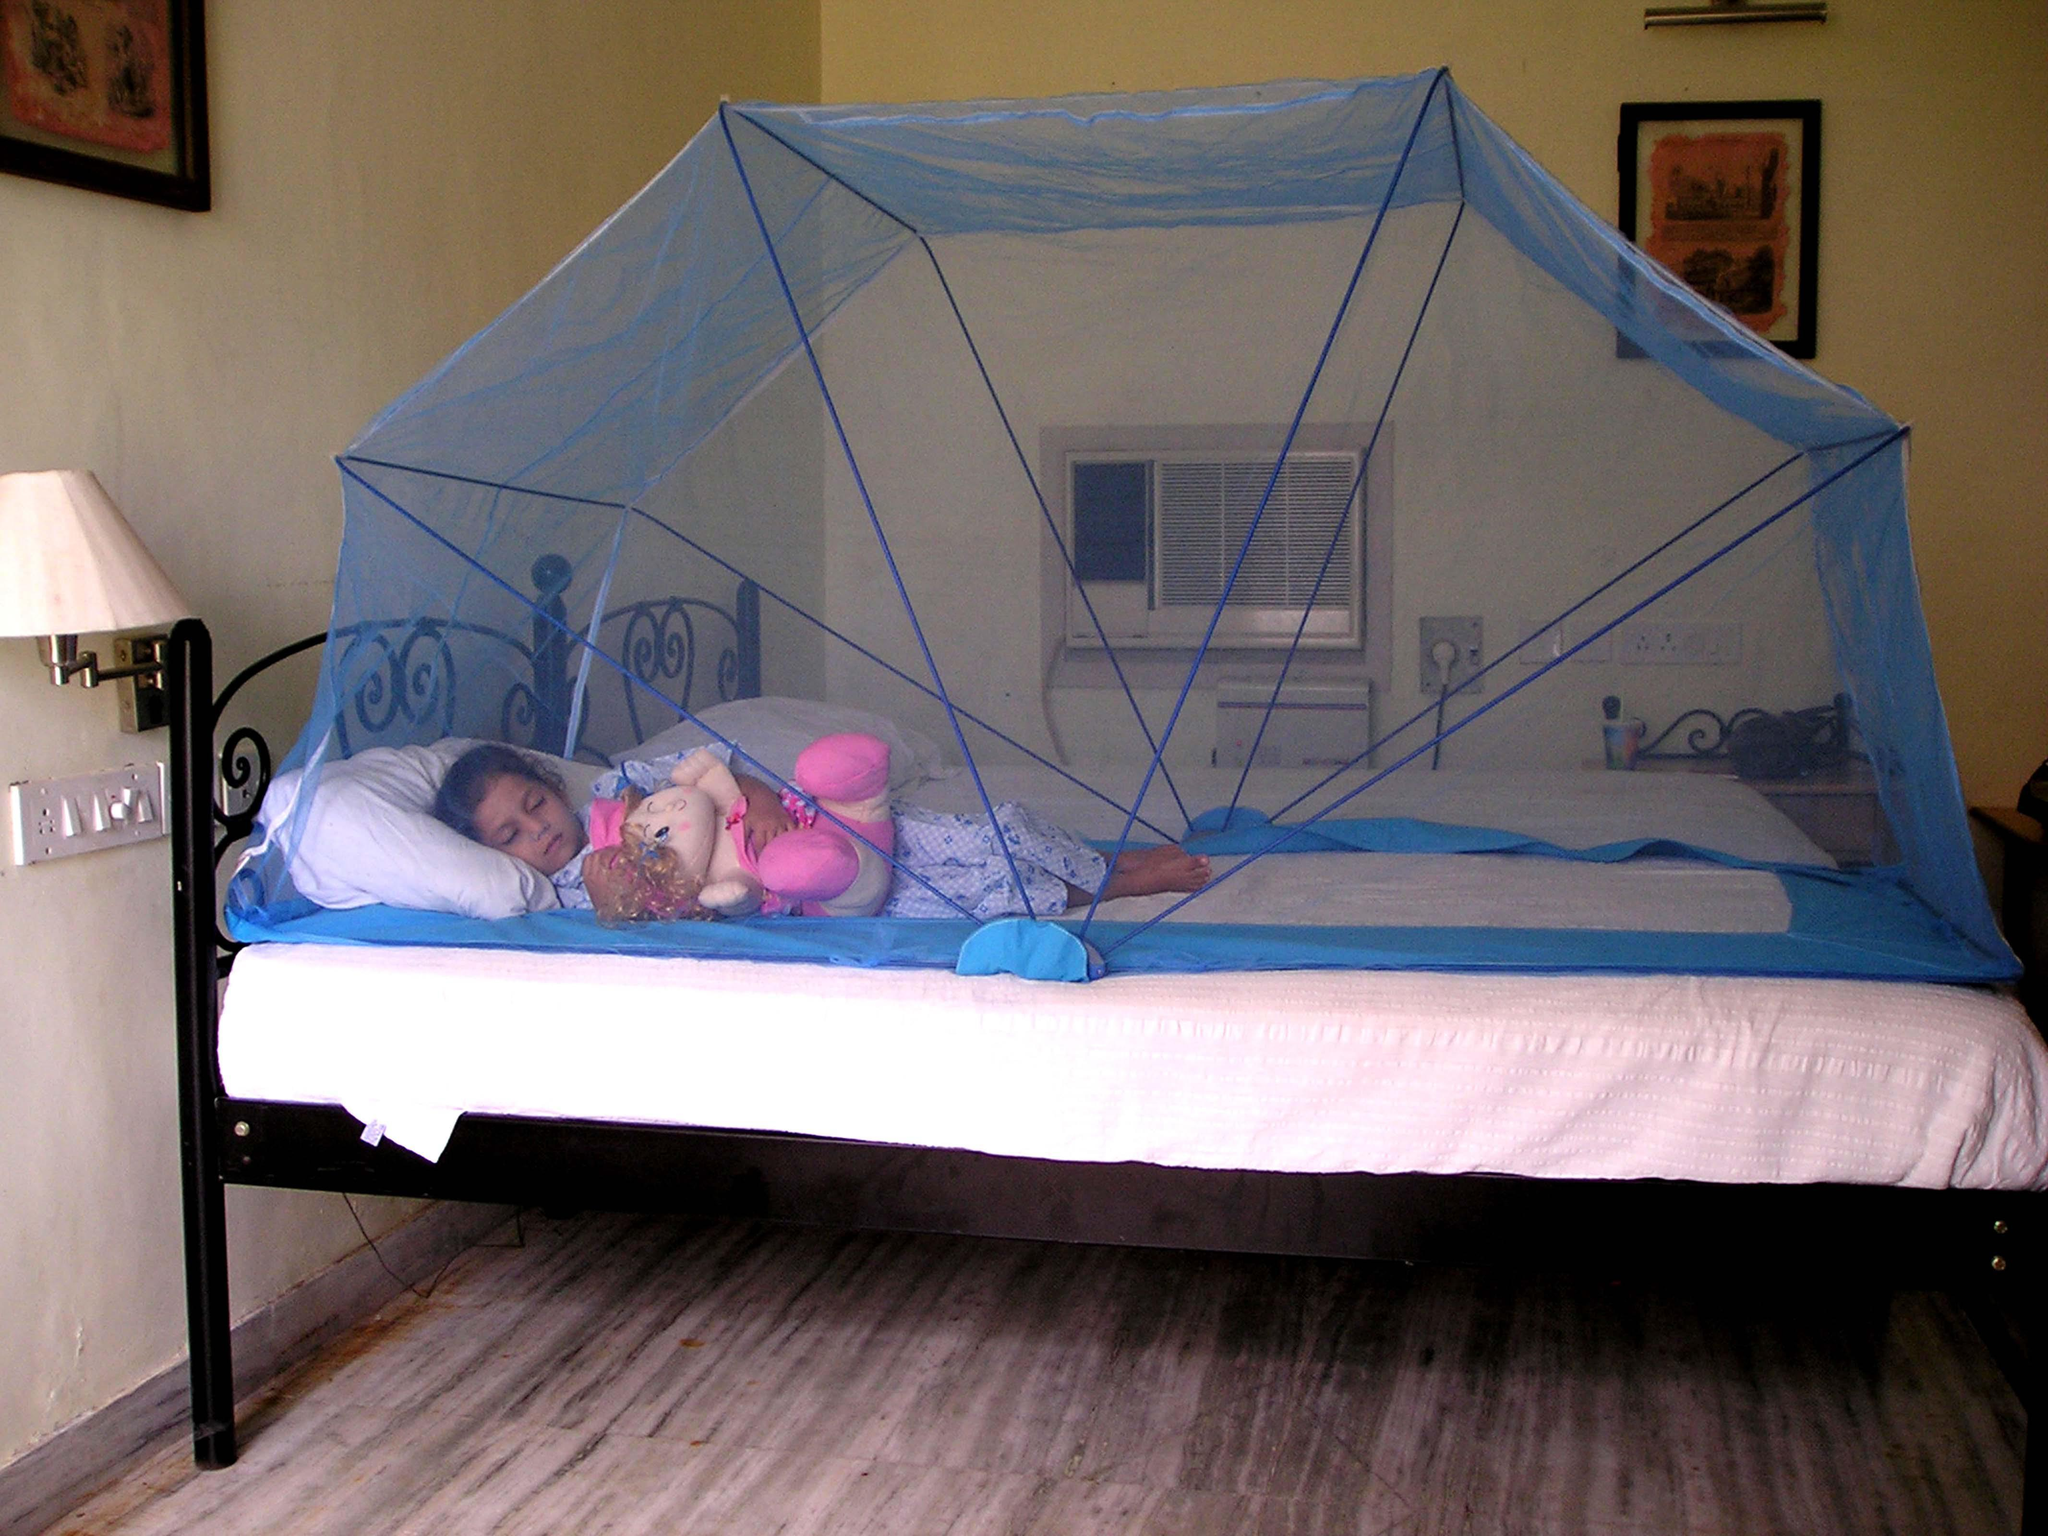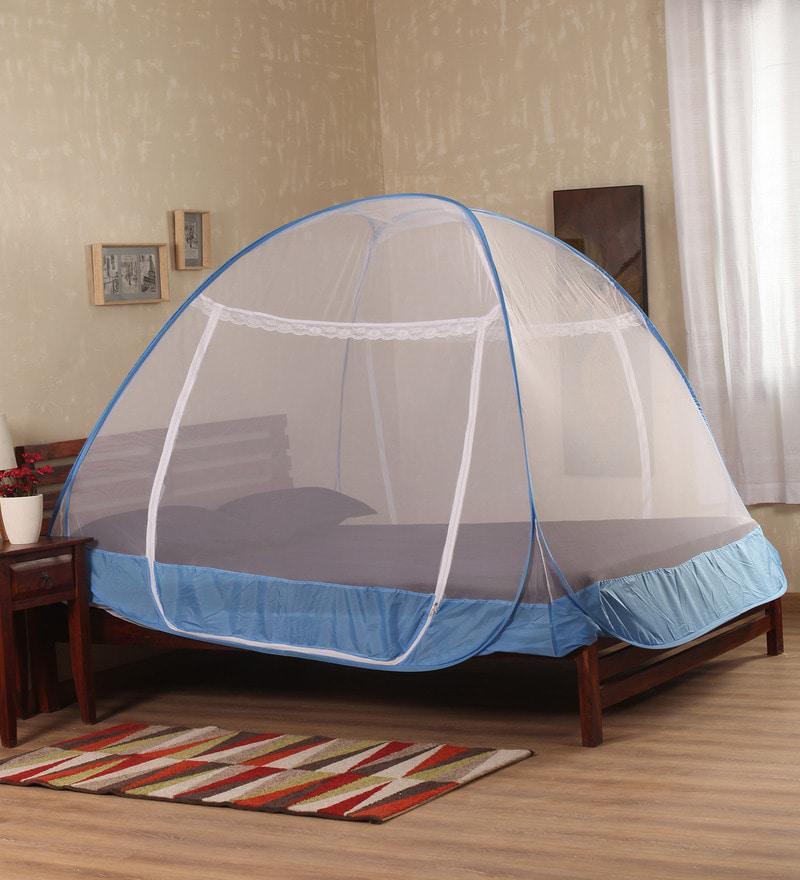The first image is the image on the left, the second image is the image on the right. For the images displayed, is the sentence "The left image shows a dome canopy with an open side." factually correct? Answer yes or no. No. 